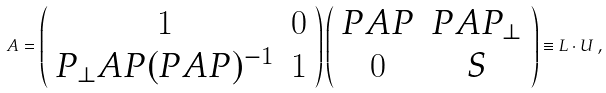Convert formula to latex. <formula><loc_0><loc_0><loc_500><loc_500>A = \left ( \begin{array} { c c } 1 & 0 \\ P _ { \perp } A P ( P A P ) ^ { - 1 } & 1 \end{array} \right ) \left ( \begin{array} { c c } P A P & P A P _ { \perp } \\ 0 & S \end{array} \right ) \equiv L \cdot U \, ,</formula> 